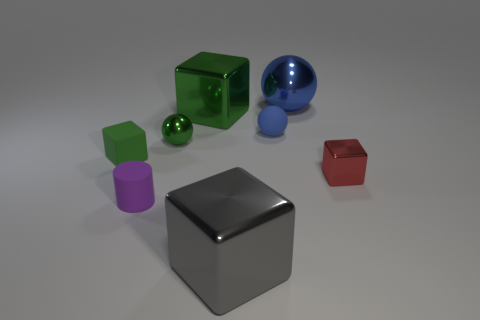Add 2 tiny purple shiny balls. How many objects exist? 10 Subtract all cylinders. How many objects are left? 7 Add 3 big metal objects. How many big metal objects exist? 6 Subtract 0 cyan cylinders. How many objects are left? 8 Subtract all small matte blocks. Subtract all blue rubber balls. How many objects are left? 6 Add 3 cylinders. How many cylinders are left? 4 